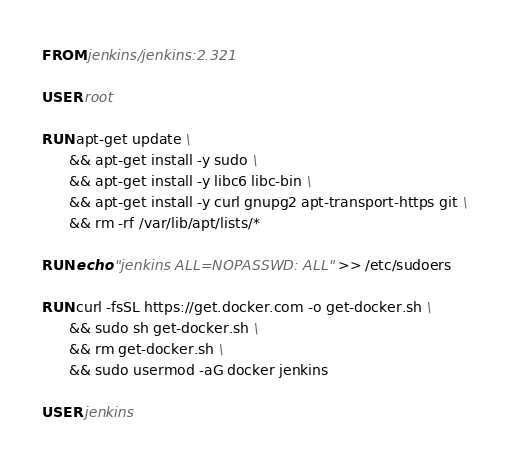<code> <loc_0><loc_0><loc_500><loc_500><_Dockerfile_>FROM jenkins/jenkins:2.321

USER root

RUN apt-get update \
      && apt-get install -y sudo \
      && apt-get install -y libc6 libc-bin \
      && apt-get install -y curl gnupg2 apt-transport-https git \
      && rm -rf /var/lib/apt/lists/*

RUN echo "jenkins ALL=NOPASSWD: ALL" >> /etc/sudoers

RUN curl -fsSL https://get.docker.com -o get-docker.sh \
      && sudo sh get-docker.sh \
      && rm get-docker.sh \
      && sudo usermod -aG docker jenkins

USER jenkins
</code> 